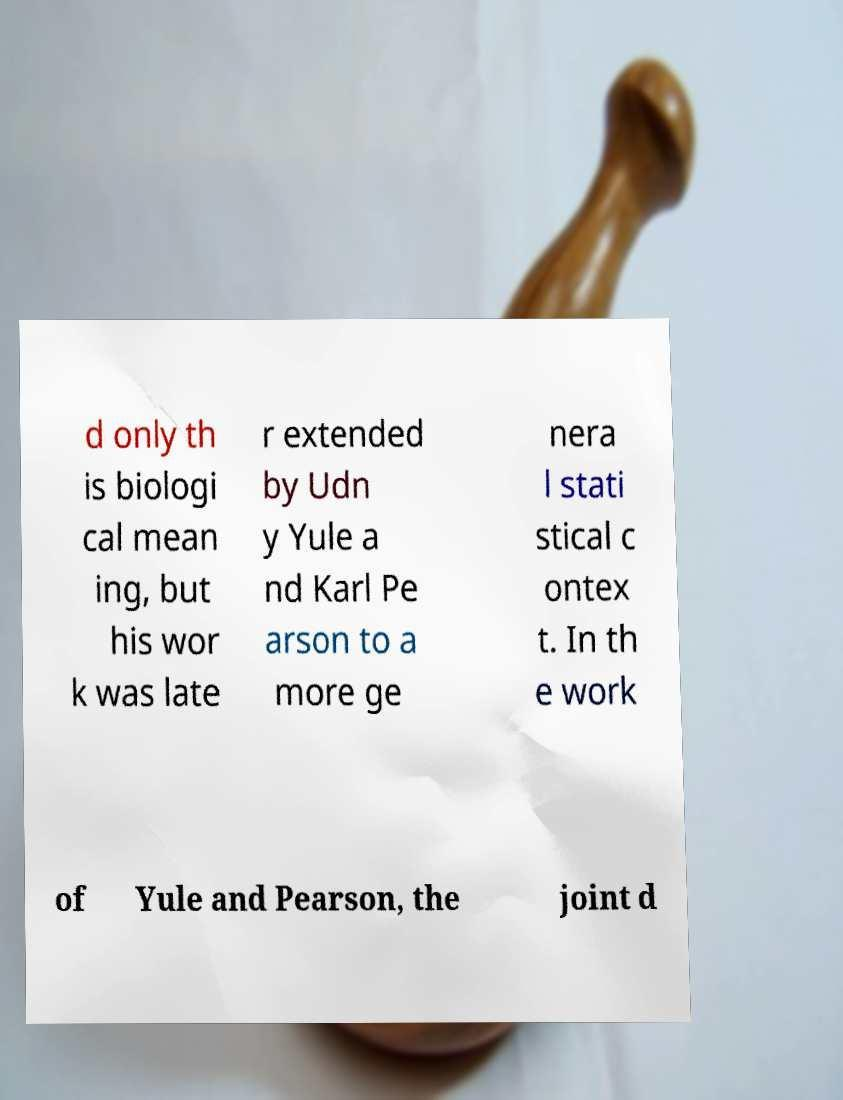Can you read and provide the text displayed in the image?This photo seems to have some interesting text. Can you extract and type it out for me? d only th is biologi cal mean ing, but his wor k was late r extended by Udn y Yule a nd Karl Pe arson to a more ge nera l stati stical c ontex t. In th e work of Yule and Pearson, the joint d 